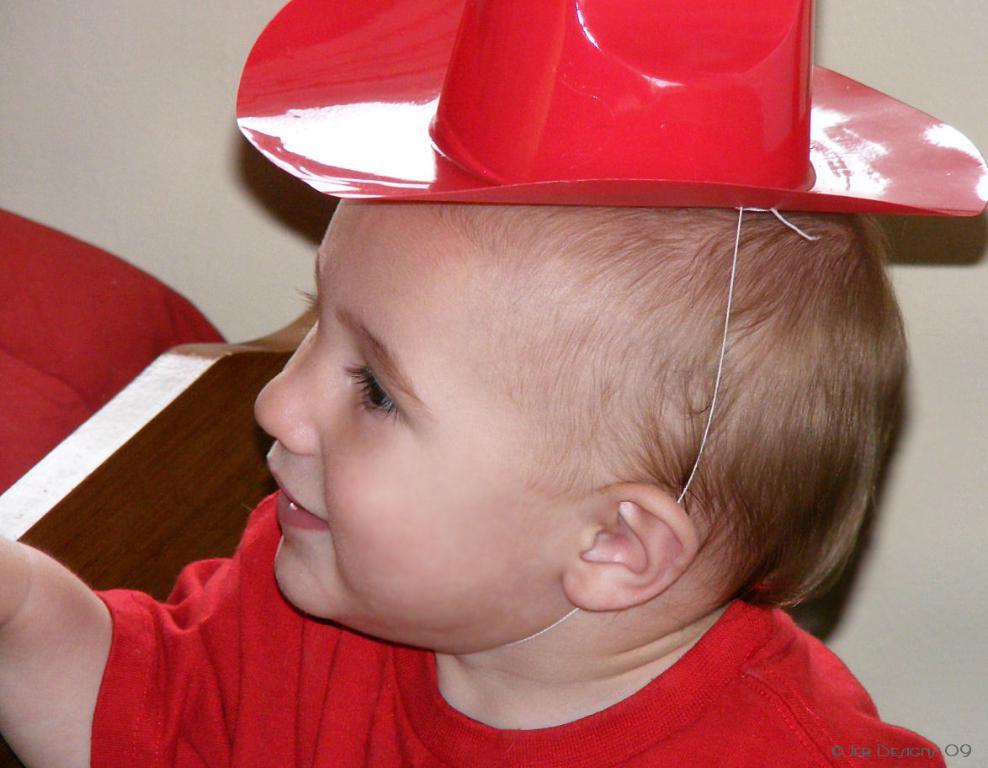How would you summarize this image in a sentence or two? In the image we can see a baby wearing red clothes, cap and the baby is smiling. The background is white and this is a watermark. 